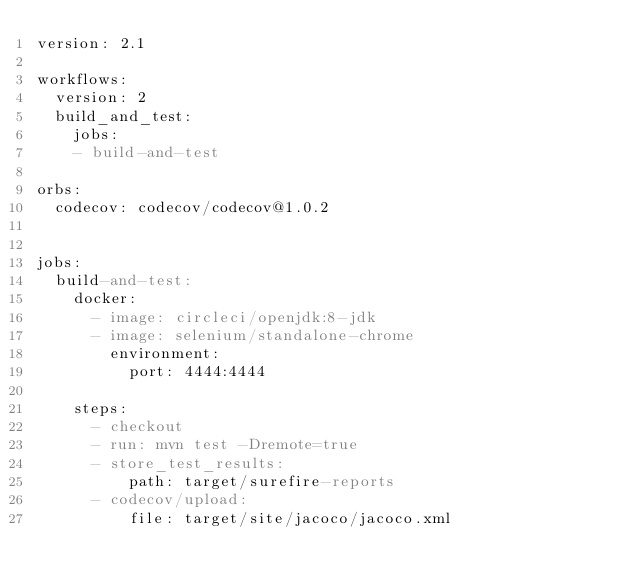Convert code to text. <code><loc_0><loc_0><loc_500><loc_500><_YAML_>version: 2.1

workflows:
  version: 2
  build_and_test:
    jobs:
    - build-and-test

orbs:
  codecov: codecov/codecov@1.0.2


jobs:
  build-and-test:
    docker:
      - image: circleci/openjdk:8-jdk
      - image: selenium/standalone-chrome
        environment:
          port: 4444:4444

    steps:
      - checkout
      - run: mvn test -Dremote=true
      - store_test_results:
          path: target/surefire-reports
      - codecov/upload:
          file: target/site/jacoco/jacoco.xml

</code> 